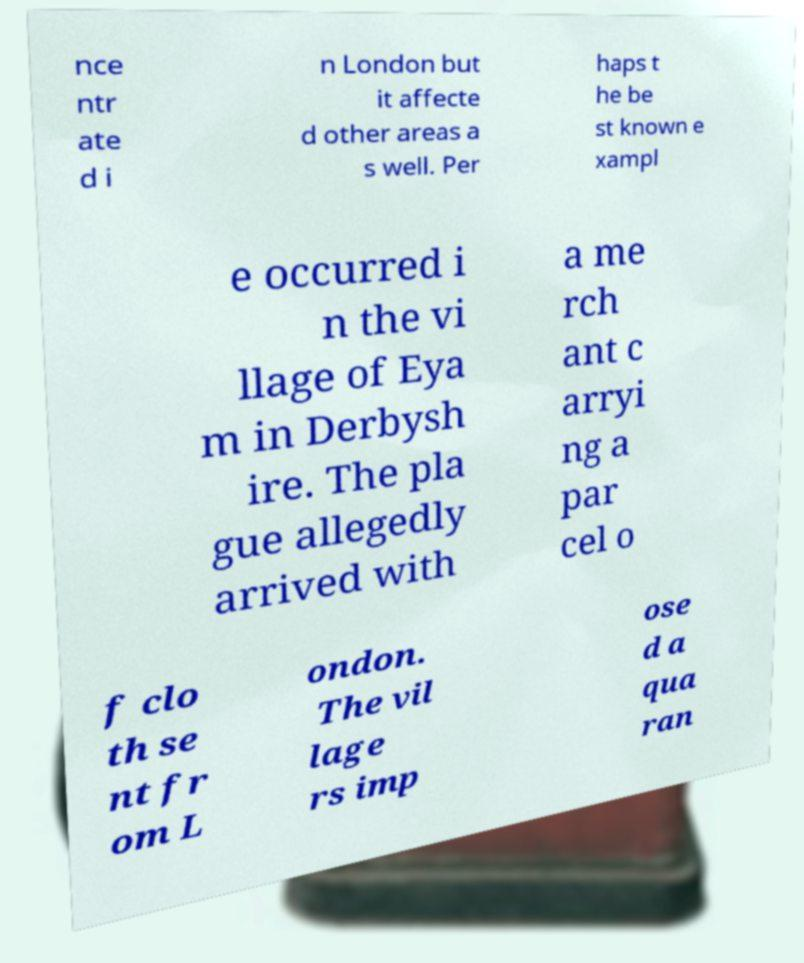Please read and relay the text visible in this image. What does it say? nce ntr ate d i n London but it affecte d other areas a s well. Per haps t he be st known e xampl e occurred i n the vi llage of Eya m in Derbysh ire. The pla gue allegedly arrived with a me rch ant c arryi ng a par cel o f clo th se nt fr om L ondon. The vil lage rs imp ose d a qua ran 